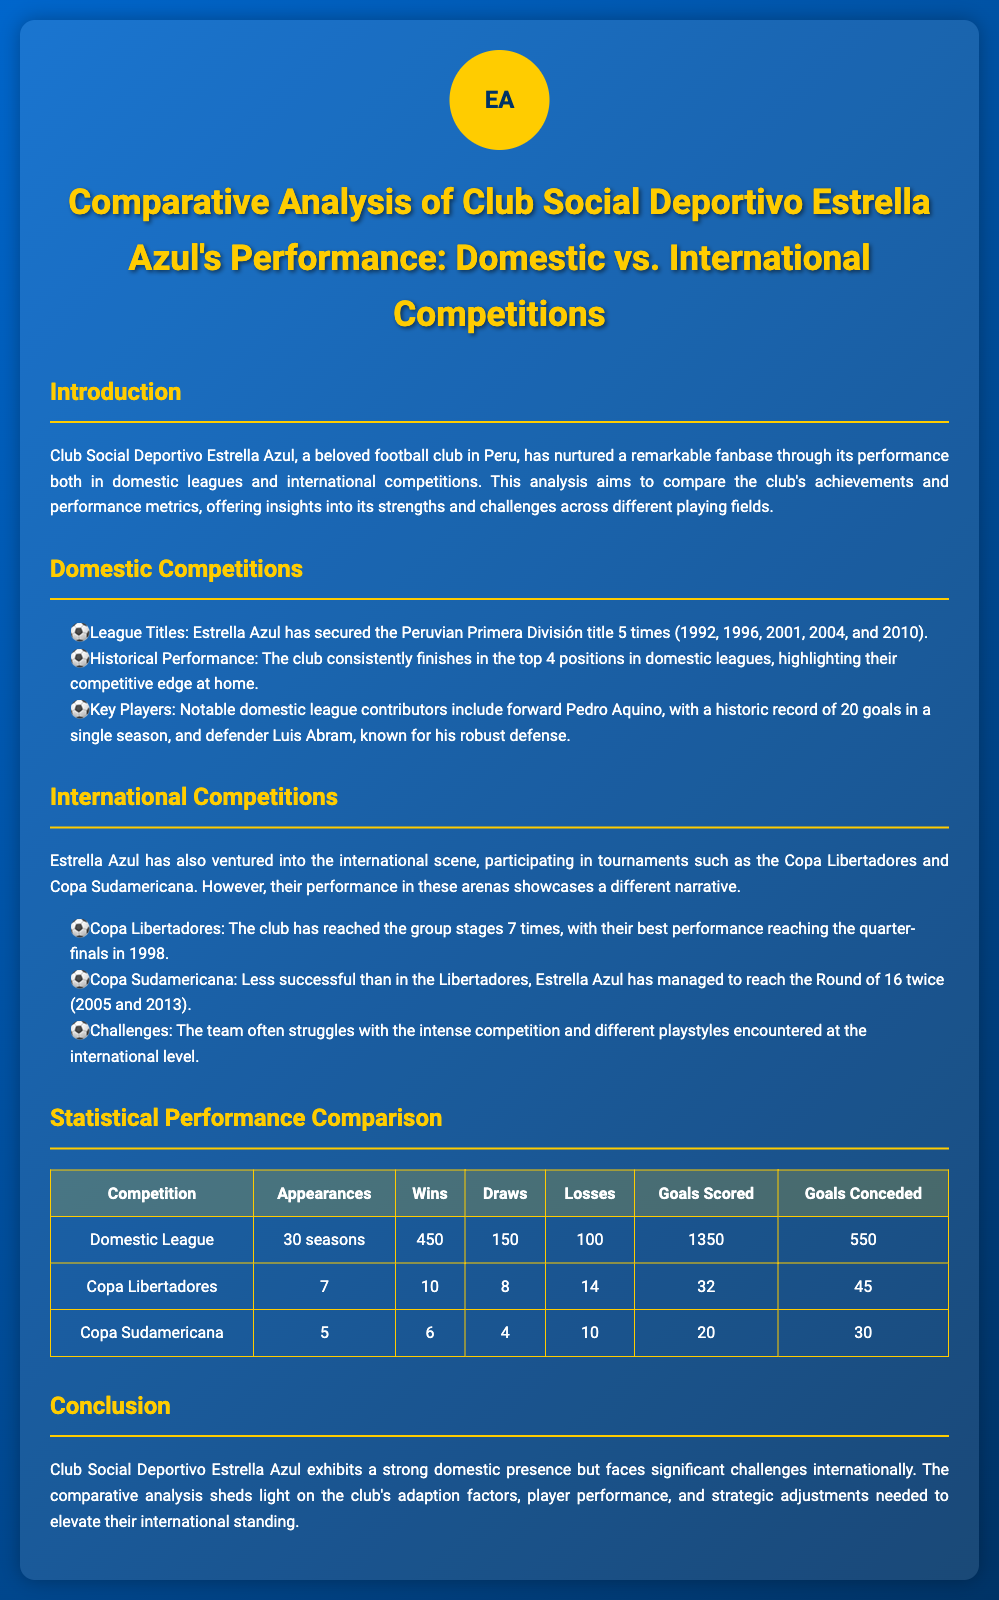what year did Estrella Azul last win the league title? The document lists the years Estrella Azul won the Peruvian Primera División title, with the last being 2010.
Answer: 2010 how many times has Estrella Azul reached the Copa Libertadores group stages? The document states that Estrella Azul has reached the group stages of the Copa Libertadores 7 times.
Answer: 7 what is Estrella Azul's record for goals scored in the domestic league? The document mentions that Pedro Aquino scored a historic record of 20 goals in a single domestic season.
Answer: 20 how many total appearances has Estrella Azul made in the Copa Sudamericana? The document specifies that the club has participated in the Copa Sudamericana 5 times.
Answer: 5 what is the total number of losses recorded by Estrella Azul in Copa Libertadores? According to the document, Estrella Azul has recorded 14 losses in the Copa Libertadores.
Answer: 14 which player is noted for their robust defense in domestic leagues? The document identifies defender Luis Abram as known for his robust defense.
Answer: Luis Abram how many goals did Estrella Azul score in the domestic league? The document indicates that Estrella Azul scored a total of 1350 goals in the domestic league.
Answer: 1350 how many times has Estrella Azul reached the Round of 16 in the Copa Sudamericana? The document notes that Estrella Azul reached the Round of 16 twice in the Copa Sudamericana.
Answer: 2 what is the best performance of Estrella Azul in Copa Libertadores? The document mentions that Estrella Azul's best performance in the Copa Libertadores was reaching the quarter-finals in 1998.
Answer: quarter-finals 